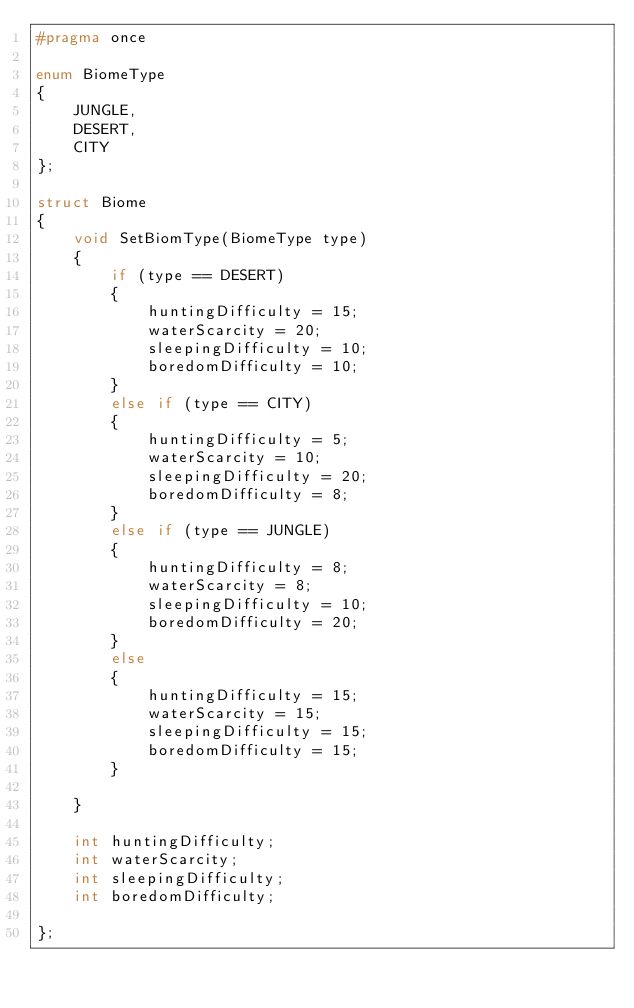Convert code to text. <code><loc_0><loc_0><loc_500><loc_500><_C_>#pragma once

enum BiomeType
{
	JUNGLE,
	DESERT,
	CITY
};

struct Biome
{
	void SetBiomType(BiomeType type)
	{
		if (type == DESERT)
		{
			huntingDifficulty = 15;
			waterScarcity = 20;
			sleepingDifficulty = 10;
			boredomDifficulty = 10;
		}
		else if (type == CITY)
		{
			huntingDifficulty = 5;
			waterScarcity = 10;
			sleepingDifficulty = 20;
			boredomDifficulty = 8;
		}
		else if (type == JUNGLE)
		{
			huntingDifficulty = 8;
			waterScarcity = 8;
			sleepingDifficulty = 10;
			boredomDifficulty = 20;
		}
		else
		{
			huntingDifficulty = 15;
			waterScarcity = 15;
			sleepingDifficulty = 15;
			boredomDifficulty = 15;
		}
		
	}

	int huntingDifficulty;
	int waterScarcity;
	int sleepingDifficulty;
	int boredomDifficulty;
	
};</code> 